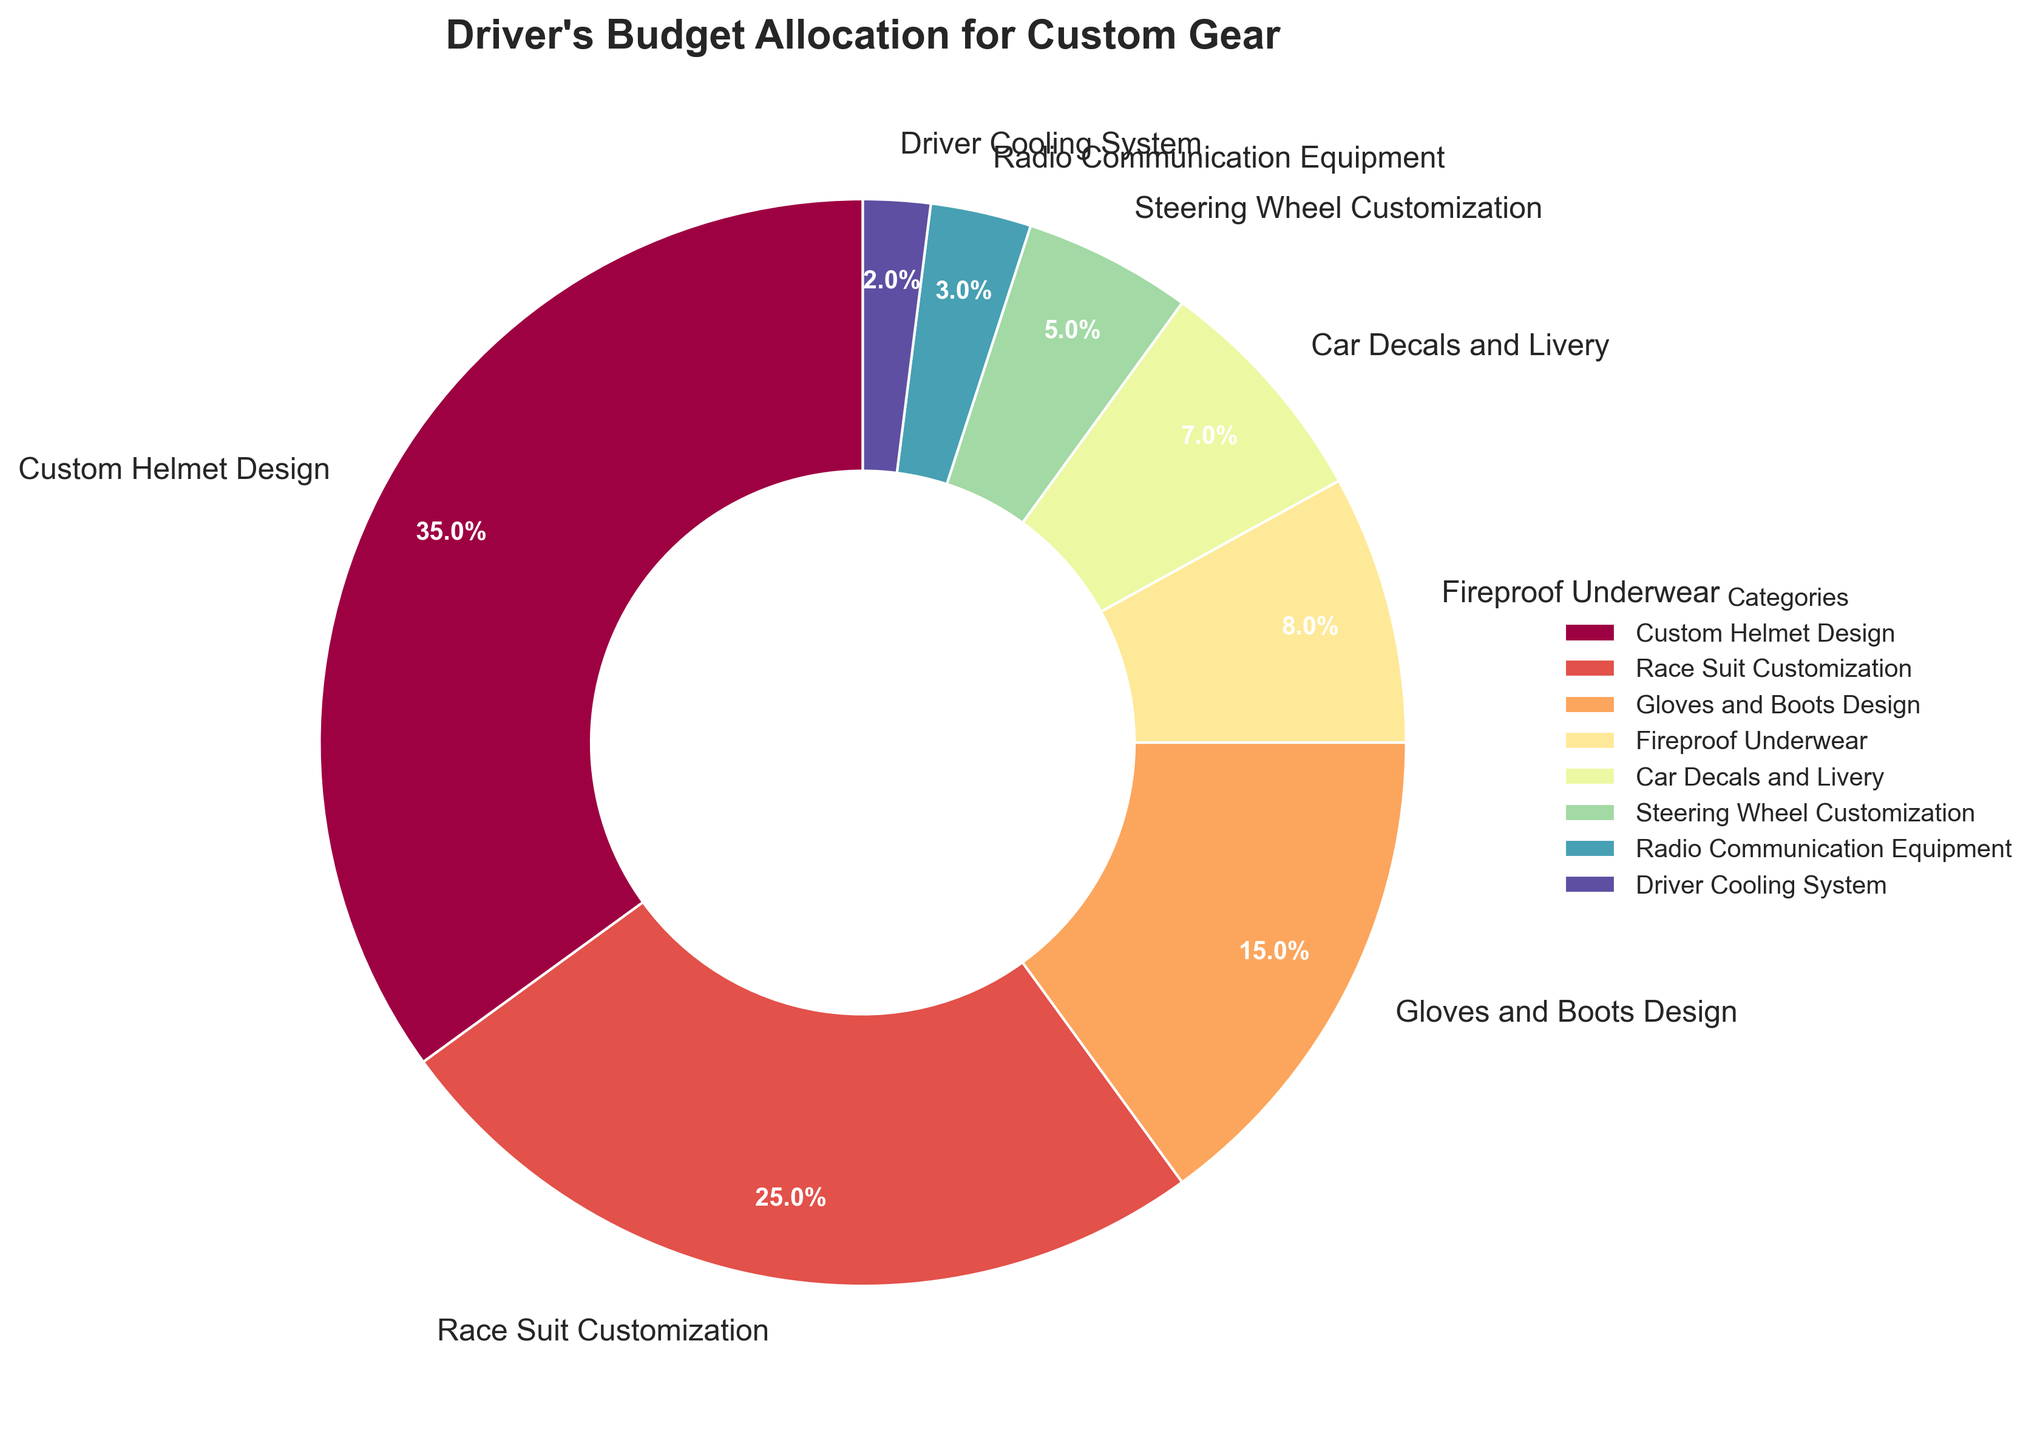What is the largest portion of the driver's budget allocated to? The figure shows that the category "Custom Helmet Design" has the largest wedge in the pie chart.
Answer: Custom Helmet Design Which two categories together make up exactly 50% of the budget? The figure indicates that "Custom Helmet Design" constitutes 35% and "Race Suit Customization" constitutes 25%. Adding these together (35% + 25%) gives 60%. Therefore, no two categories add up to 50%.
Answer: None What is the combined percentage allocated to gloves, boots, and fireproof underwear? The figure shows that "Gloves and Boots Design" is 15% and "Fireproof Underwear" is 8%. Adding these together (15% + 8%) gives 23%.
Answer: 23% How much more is spent on race suit customization than on car decals and livery? The figure shows "Race Suit Customization" at 25% and "Car Decals and Livery" at 7%. The difference is 25% - 7% = 18%.
Answer: 18% Which category receives the smallest portion of the budget? The figure illustrates that "Driver Cooling System" receives 2%, which is the smallest portion.
Answer: Driver Cooling System How do the budget allocations for radio communication equipment and steering wheel customization compare? The figure indicates that "Radio Communication Equipment" is 3% and "Steering Wheel Customization" is 5%. Since 5% > 3%, more is spent on steering wheel customization.
Answer: More is spent on steering wheel customization What is the total budget allocation percentage for design-related categories? Design-related categories include "Custom Helmet Design" (35%), "Race Suit Customization" (25%), "Gloves and Boots Design" (15%), and "Car Decals and Livery" (7%). Adding these gives 35% + 25% + 15% + 7% = 82%.
Answer: 82% Does any category have a budget allocation between 5% and 10%? The figure shows "Fireproof Underwear" at 8% and "Car Decals and Livery" at 7%, both of which are between 5% and 10%.
Answer: Yes Which categories make up less than 10% of the budget? The figure indicates that "Fireproof Underwear" at 8%, "Car Decals and Livery" at 7%, "Steering Wheel Customization" at 5%, "Radio Communication Equipment" at 3%, and "Driver Cooling System" at 2% all make up less than 10%.
Answer: Fireproof Underwear, Car Decals and Livery, Steering Wheel Customization, Radio Communication Equipment, Driver Cooling System 